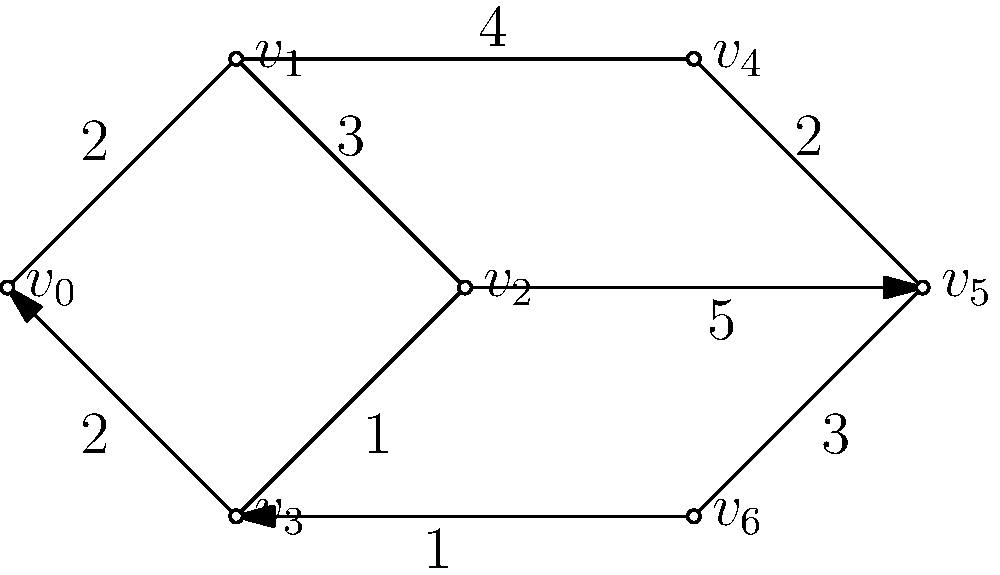In the network diagram above, vertices represent tech companies and edges represent strategic partnerships, with edge weights indicating the strength of the partnership (higher weight = stronger partnership). What is the minimum number of partnerships that need to be traversed to connect all companies in the most efficient way, and what is the total strength of these partnerships? To solve this problem, we need to find the Minimum Spanning Tree (MST) of the graph. The MST connects all vertices (companies) with the minimum total edge weight (partnership strength). We'll use Kruskal's algorithm to find the MST:

1. Sort all edges by weight in ascending order:
   $(v_3, v_6): 1$, $(v_2, v_3): 1$, $(v_0, v_1): 2$, $(v_0, v_3): 2$, $(v_4, v_5): 2$, $(v_1, v_2): 3$, $(v_5, v_6): 3$, $(v_1, v_4): 4$, $(v_2, v_5): 5$

2. Start with an empty set of edges and add edges in order, skipping those that would create a cycle:
   - Add $(v_3, v_6): 1$
   - Add $(v_2, v_3): 1$
   - Add $(v_0, v_1): 2$
   - Add $(v_4, v_5): 2$
   - Add $(v_1, v_2): 3$ (completes the MST)

3. The MST now includes 5 edges, connecting all 7 vertices.

4. Calculate the total strength by summing the weights of the selected edges:
   $1 + 1 + 2 + 2 + 3 = 9$

Therefore, the minimum number of partnerships needed is 5, and the total strength of these partnerships is 9.
Answer: 5 partnerships, total strength 9 